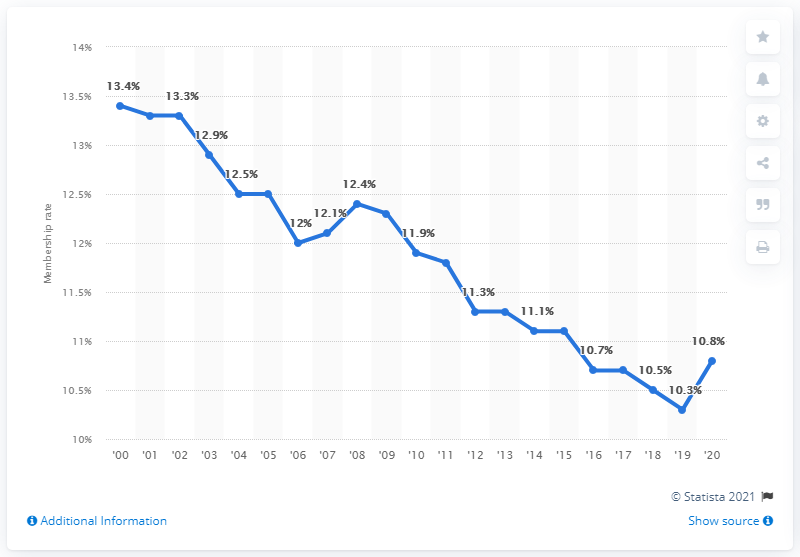Highlight a few significant elements in this photo. In 2020, the union membership rate was 10.8%. 